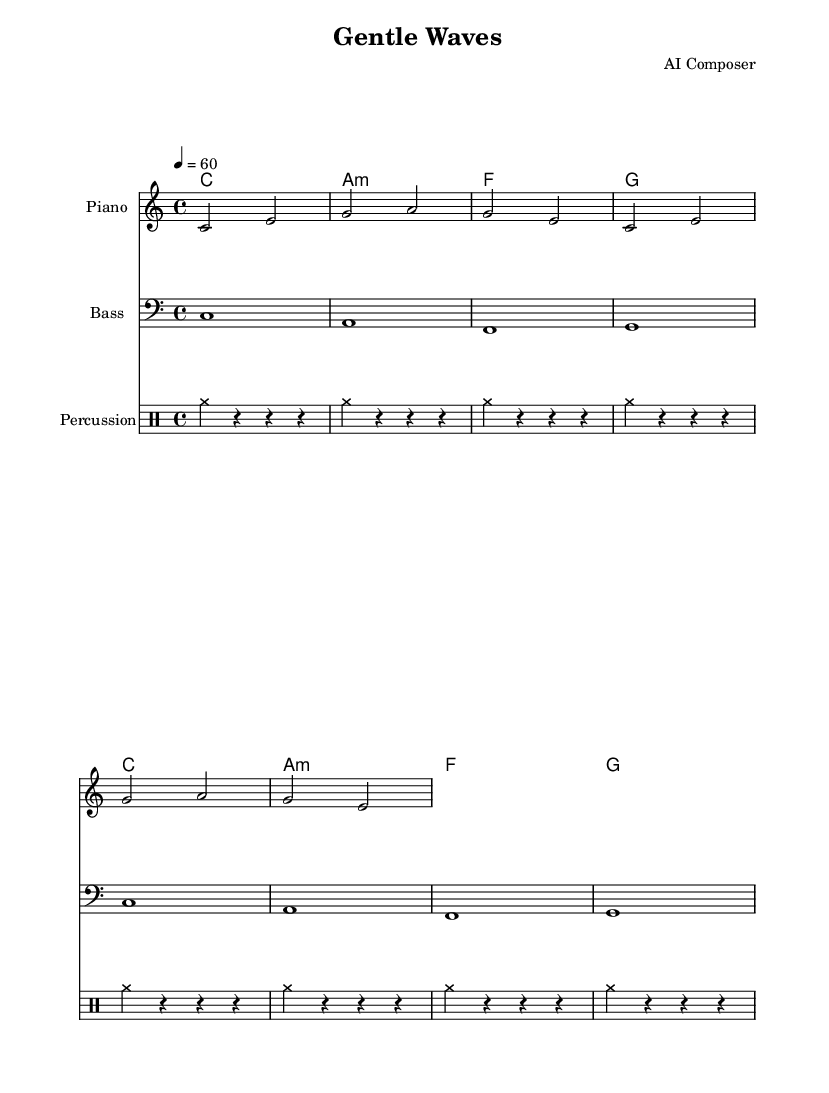What is the key signature of this music? The key signature is indicated at the beginning of the staff. It shows no sharps or flats, which corresponds to C major.
Answer: C major What is the time signature of this music? The time signature is shown at the beginning of the staff notation. It displays "4/4," meaning there are four beats per measure, and a quarter note receives one beat.
Answer: 4/4 What is the tempo marking of this music? The tempo marking is found at the start of the score. The indication "4 = 60" means there are 60 beats per minute, which is a moderate pace.
Answer: 60 How many measures are in the melody? By counting the individual measures in the melody section, we find there are four measures total. Each line consists of two measures.
Answer: 4 What type of musical form does this piece represent? The piece consists of repeated phrases, which indicates a simple ABA or through-composed form often found in ambient dance music. The consistent harmonic and melodic structure supports this.
Answer: Repeated phrases What instruments are used in this sheet music? The instruments are specified at the beginning of each staff: a piano for the melody, bass for the bass line, and percussion for the drum part.
Answer: Piano, Bass, Percussion What is the total duration of the piece based on the melody? The melody has two measures of half notes (each lasting two beats) repeated twice. Each measure consists of four beats, resulting in 16 beats total for the melody.
Answer: 16 beats 